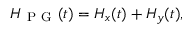<formula> <loc_0><loc_0><loc_500><loc_500>H _ { P G } ( t ) = H _ { x } ( t ) + H _ { y } ( t ) ,</formula> 